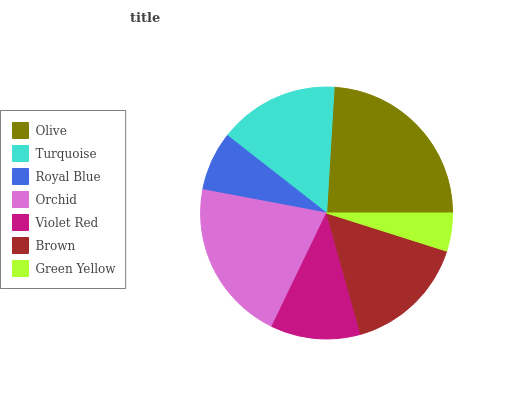Is Green Yellow the minimum?
Answer yes or no. Yes. Is Olive the maximum?
Answer yes or no. Yes. Is Turquoise the minimum?
Answer yes or no. No. Is Turquoise the maximum?
Answer yes or no. No. Is Olive greater than Turquoise?
Answer yes or no. Yes. Is Turquoise less than Olive?
Answer yes or no. Yes. Is Turquoise greater than Olive?
Answer yes or no. No. Is Olive less than Turquoise?
Answer yes or no. No. Is Turquoise the high median?
Answer yes or no. Yes. Is Turquoise the low median?
Answer yes or no. Yes. Is Olive the high median?
Answer yes or no. No. Is Orchid the low median?
Answer yes or no. No. 